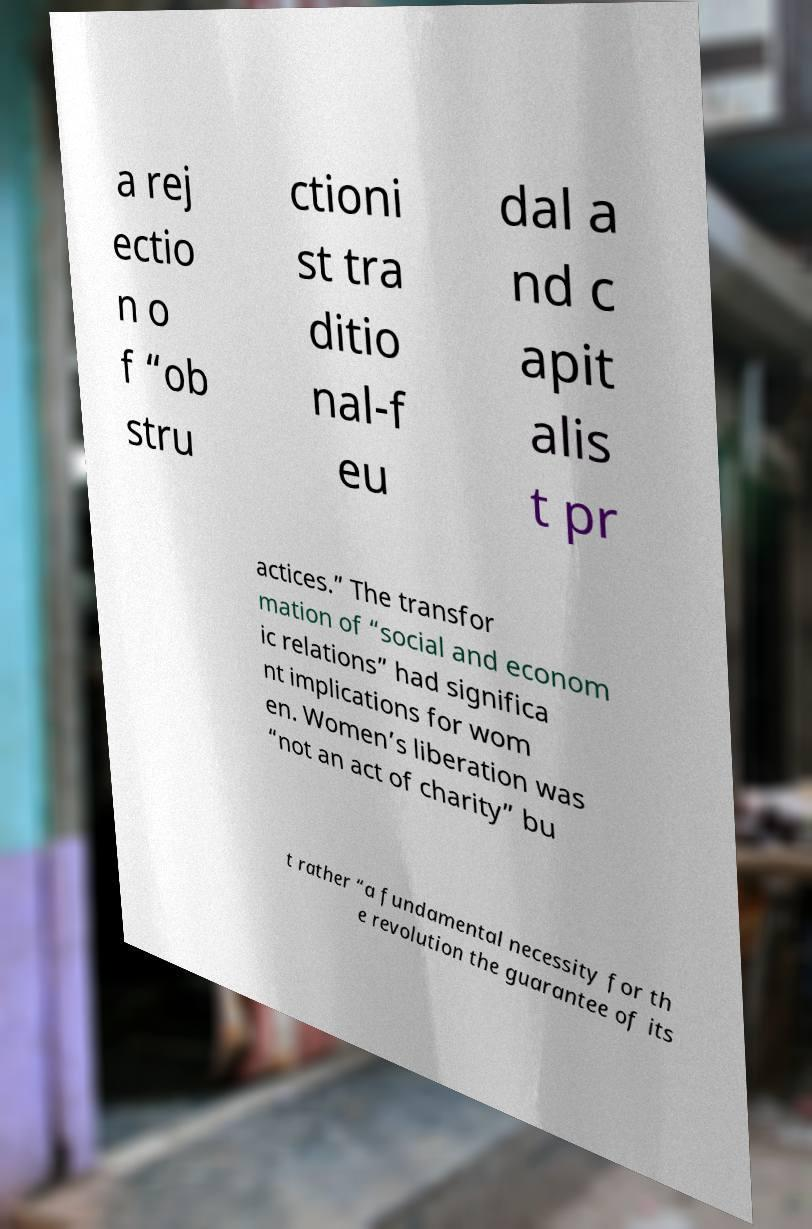Can you read and provide the text displayed in the image?This photo seems to have some interesting text. Can you extract and type it out for me? a rej ectio n o f “ob stru ctioni st tra ditio nal-f eu dal a nd c apit alis t pr actices.” The transfor mation of “social and econom ic relations” had significa nt implications for wom en. Women’s liberation was “not an act of charity” bu t rather “a fundamental necessity for th e revolution the guarantee of its 